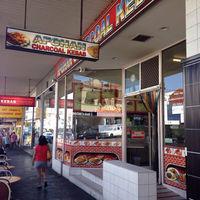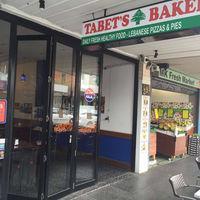The first image is the image on the left, the second image is the image on the right. Analyze the images presented: Is the assertion "There is a female wearing her hair in a high bun next to some pastries." valid? Answer yes or no. No. The first image is the image on the left, the second image is the image on the right. Examine the images to the left and right. Is the description "A woman in white with her hair in a bun stands behind a counter in one image." accurate? Answer yes or no. No. 